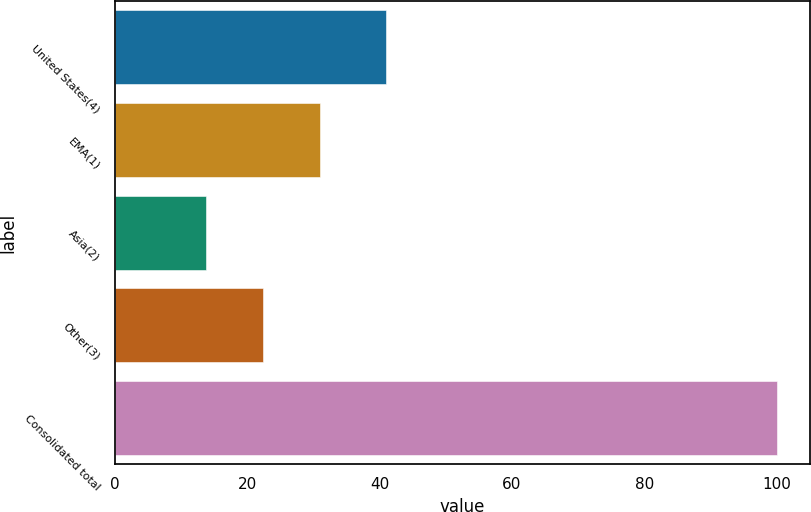Convert chart. <chart><loc_0><loc_0><loc_500><loc_500><bar_chart><fcel>United States(4)<fcel>EMA(1)<fcel>Asia(2)<fcel>Other(3)<fcel>Consolidated total<nl><fcel>41<fcel>31.04<fcel>13.8<fcel>22.42<fcel>100<nl></chart> 